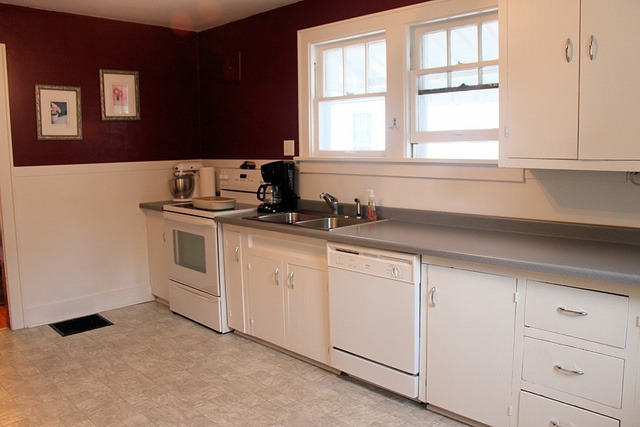Describe the objects in this image and their specific colors. I can see oven in brown, gray, tan, and maroon tones, sink in brown, maroon, black, and gray tones, bowl in brown, maroon, black, and gray tones, and bottle in brown, darkgray, tan, and maroon tones in this image. 